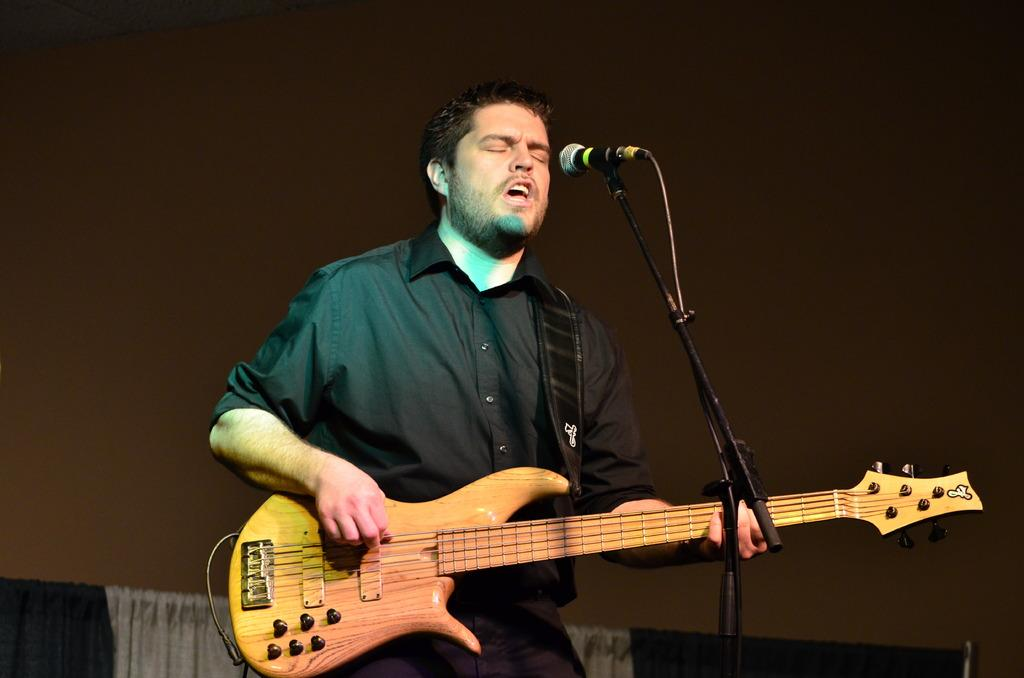What is the man in the image doing? The man is playing a guitar and singing. How is the man amplifying his voice in the image? The man is using a microphone. What type of line is the man using to pay off his debt in the image? There is no mention of debt or lines in the image; the man is playing a guitar, singing, and using a microphone. 